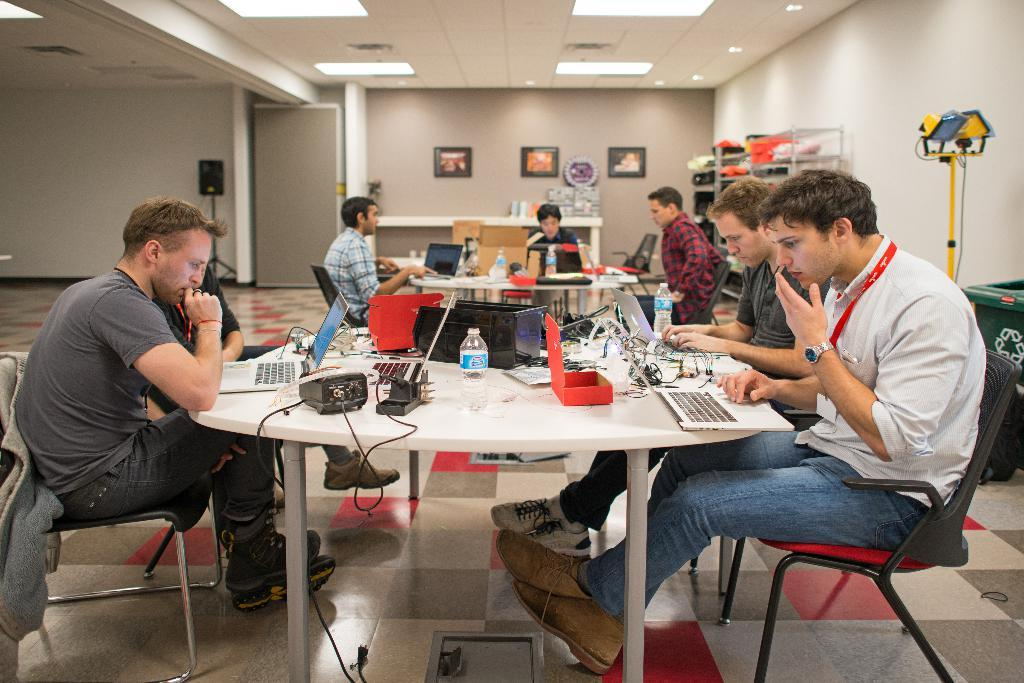What are the people in the room doing? The people in the room are operating laptops on a table. What can be found on the table in the room? The table has laptops on it. What device is present in the room for amplifying sound? There is a sound box in the room. What decorative items can be seen on the wall in the room? There are photo frames on the wall. What type of furniture is present in the room for storing items? There is a shelf with items in the room. How many cows are visible in the room? There are no cows present in the room; the image features people operating laptops in a room with a sound box, photo frames, and a shelf. 